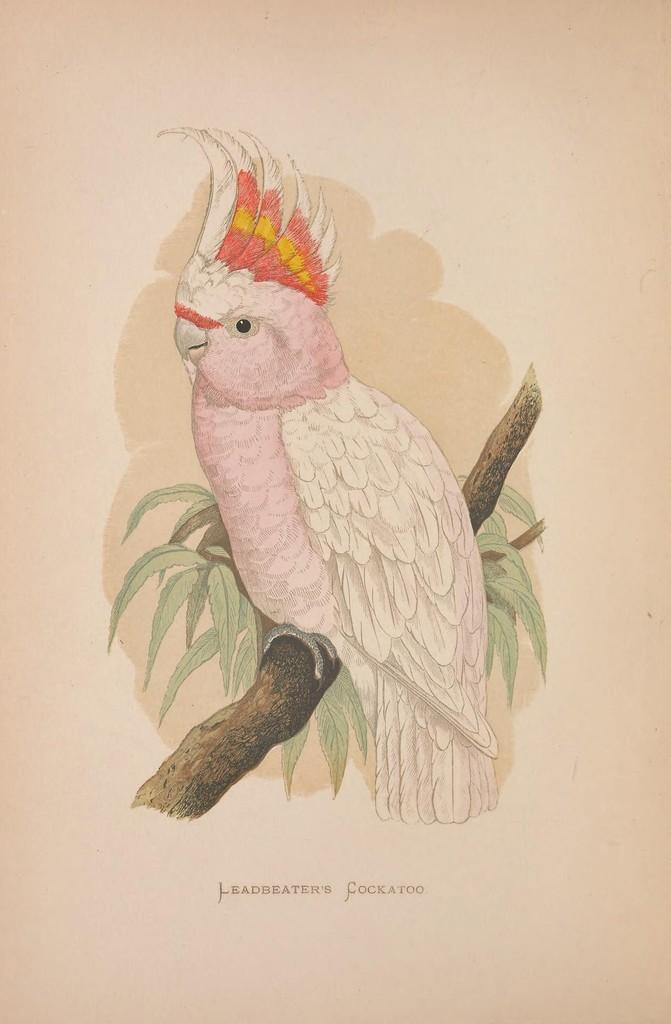What is depicted in the painting in the image? There is a painting of a bird in the image. How is the bird positioned in the painting? The bird is on a stem in the painting. What else can be seen on the stem besides the bird? There are leaves on the stem. What is written or displayed at the bottom of the image? There is text at the bottom of the image. What color is the background of the image? The background of the image is white. Can you tell me how many drawers are visible in the image? There are no drawers present in the image. What type of stem is the bird holding in the image? The bird is not holding a stem in the image; it is on a stem. 